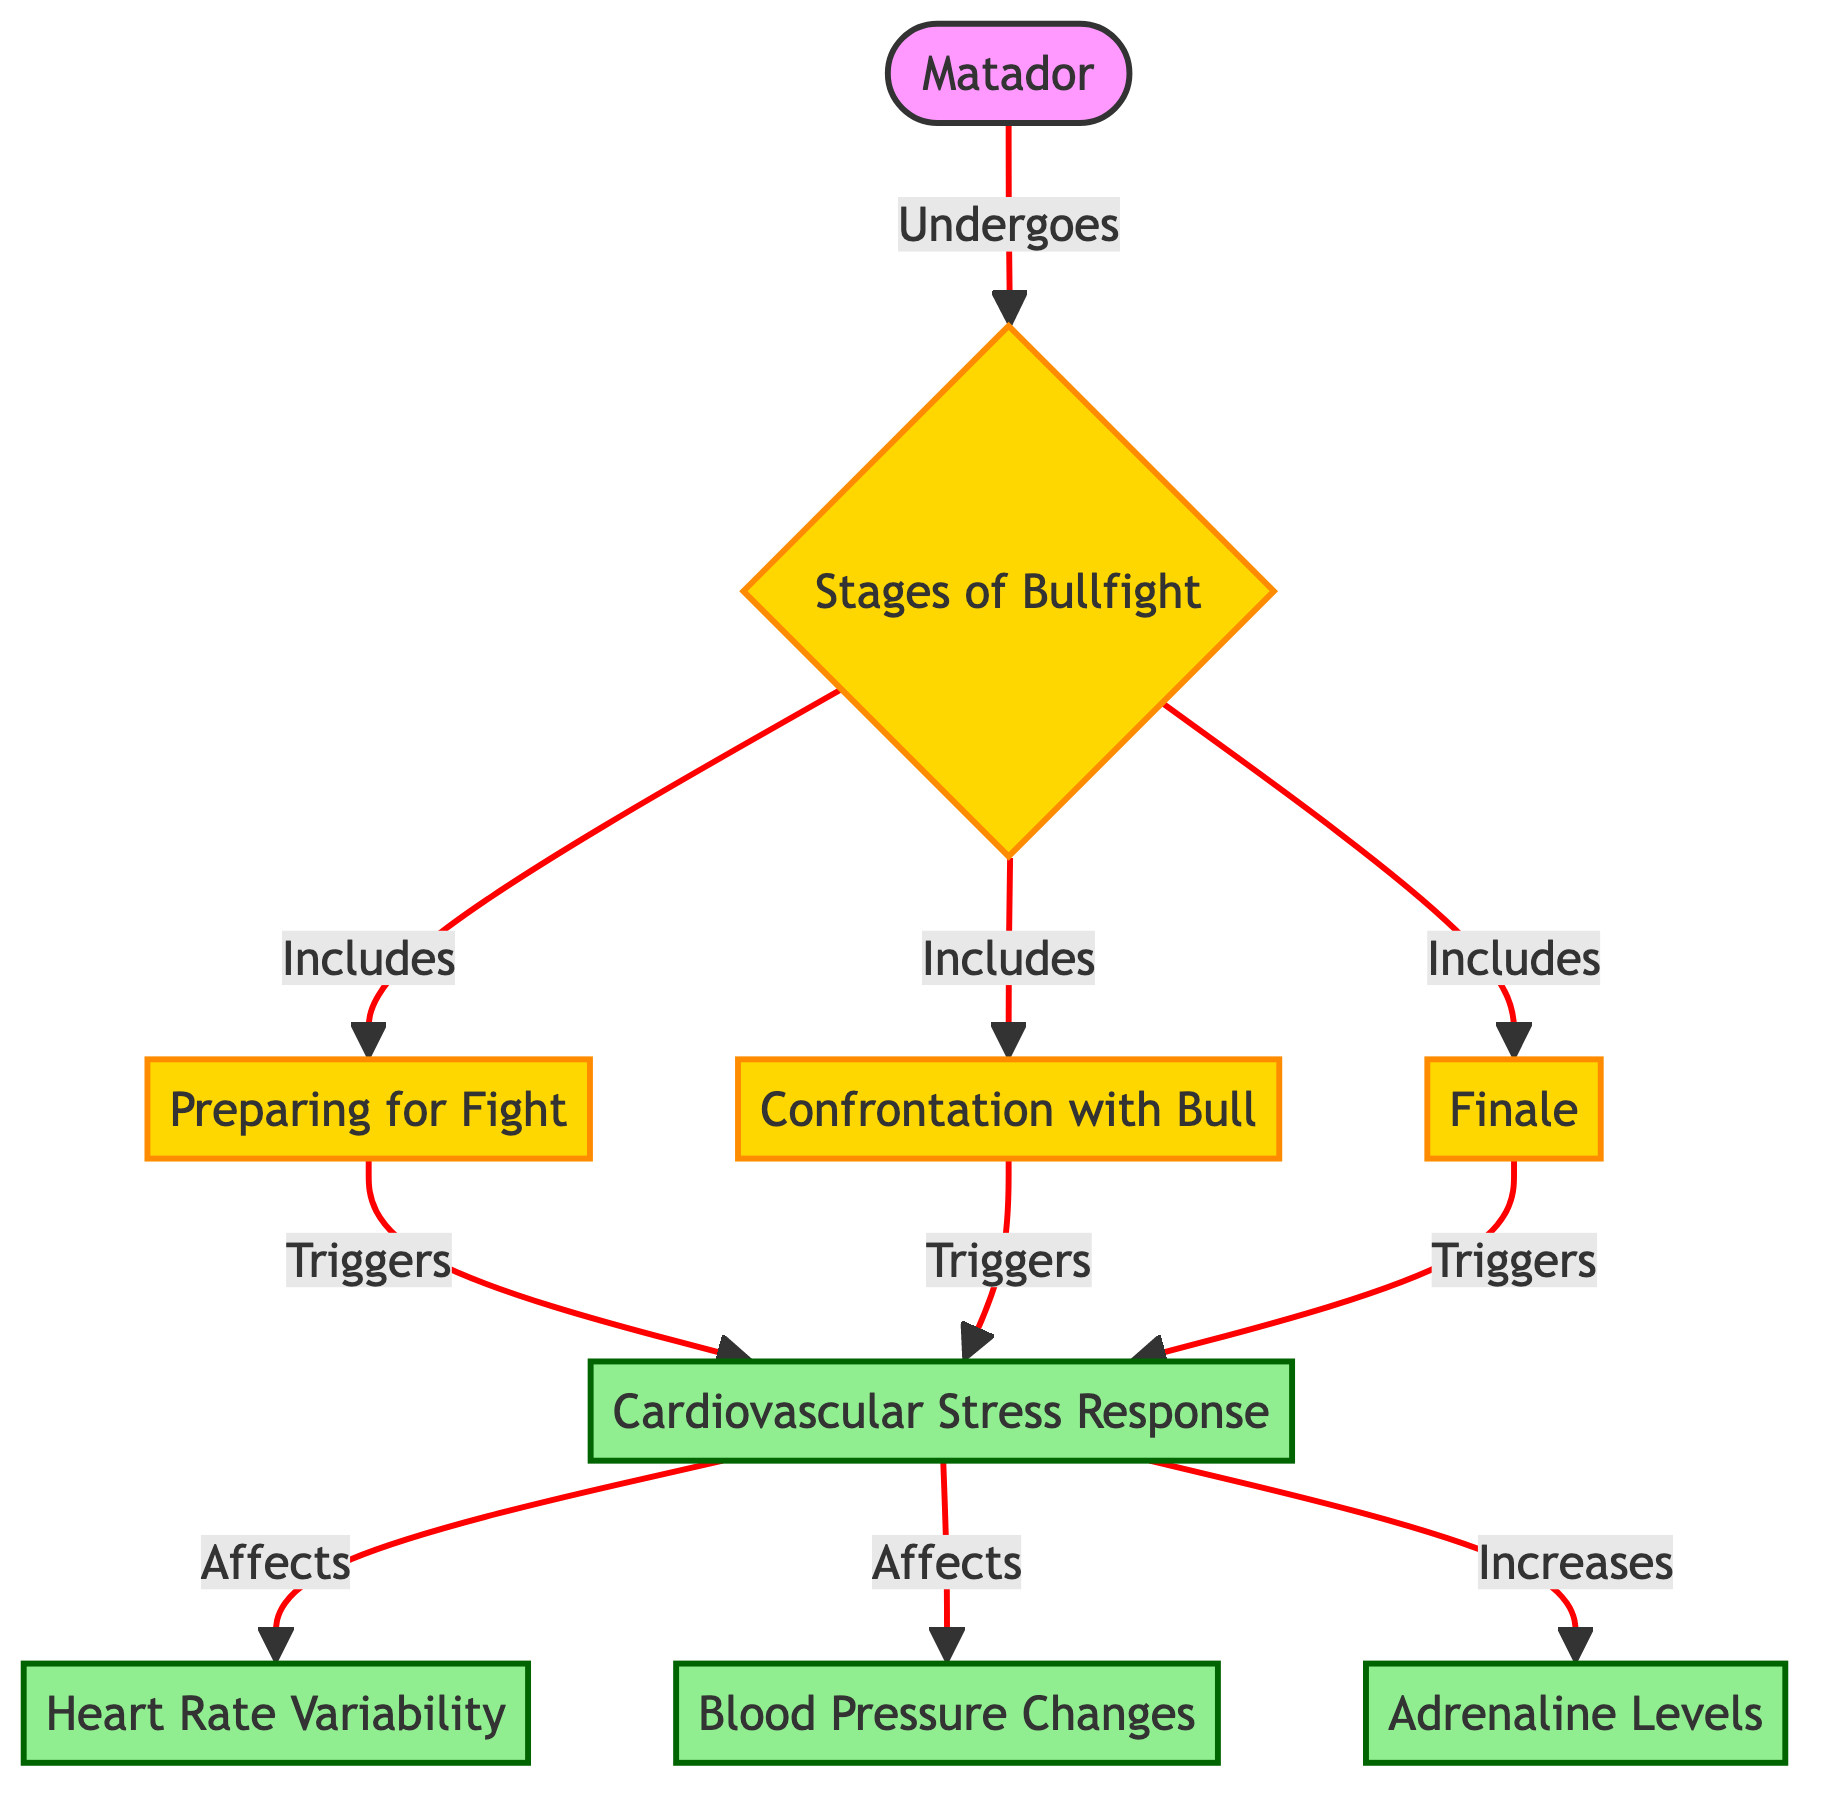What are the three stages of a bullfight listed in the diagram? The diagram lists three stages: "Preparing for Fight", "Confrontation with Bull", and "Finale". These are connected to the main node labeled "Stages of Bullfight."
Answer: Preparing for Fight, Confrontation with Bull, Finale How does the matador undergo the stages of bullfight? The diagram shows that the "Matador" node is connected to the "Stages of Bullfight" node with the relationship “Undergoes”. This indicates that the matador engages in these stages.
Answer: Undergoes Which stage of the bullfight triggers the cardiovascular stress response? The stages "Preparing for Fight", "Confrontation with Bull", and "Finale" all trigger the cardiovascular stress response, as indicated by their connections to the "Cardiovascular Stress Response" node.
Answer: All three stages What does the cardiovascular stress response affect according to the diagram? The stress response affects "Heart Rate Variability", "Blood Pressure Changes", and "Increases Adrenaline", as shown by the direct connections from the "Cardiovascular Stress Response" node to these responses.
Answer: Heart Rate Variability, Blood Pressure Changes, Adrenaline How many nodes are specifically focused on stress responses in the diagram? The stress responses in the diagram include three specific nodes: "Heart Rate Variability", "Blood Pressure Changes", and "Adrenaline Levels". Therefore, the total count of these nodes equals three.
Answer: Three What type of diagram is this and why is it categorized that way? This is a Biomedical Diagram which is categorized this way as it details physiological responses (cardiovascular stress, heart rate variability, blood pressure, and adrenaline levels) in a specific context (bullfighting).
Answer: Biomedical Diagram Which factor is explicitly mentioned to increase due to the stress response? The diagram indicates that the "Adrenaline Levels" specifically increase as a result of the cardiovascular stress response, denoting its role in heightened body functions during stress.
Answer: Adrenaline Levels What is indicated in the diagram as a connection between the "Stages of Bullfight" and the "Matador"? The diagram shows a direct connection where the matador “Undergoes” the stages of the bullfight, highlighting the role of the matador in this traditional practice.
Answer: Undergoes 